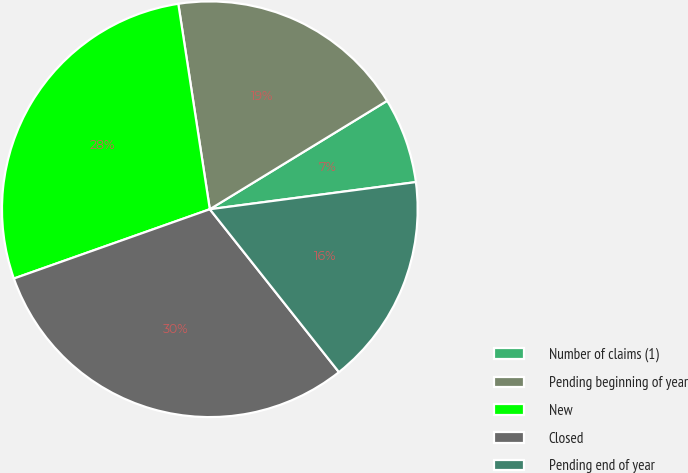Convert chart to OTSL. <chart><loc_0><loc_0><loc_500><loc_500><pie_chart><fcel>Number of claims (1)<fcel>Pending beginning of year<fcel>New<fcel>Closed<fcel>Pending end of year<nl><fcel>6.65%<fcel>18.69%<fcel>27.99%<fcel>30.26%<fcel>16.42%<nl></chart> 